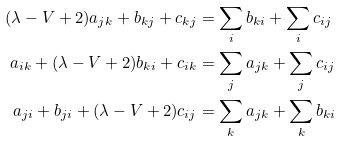<formula> <loc_0><loc_0><loc_500><loc_500>( \lambda - V + 2 ) a _ { j k } + b _ { k j } + c _ { k j } & = \sum _ { i } b _ { k i } + \sum _ { i } c _ { i j } \\ a _ { i k } + ( \lambda - V + 2 ) b _ { k i } + c _ { i k } & = \sum _ { j } a _ { j k } + \sum _ { j } c _ { i j } \\ a _ { j i } + b _ { j i } + ( \lambda - V + 2 ) c _ { i j } & = \sum _ { k } a _ { j k } + \sum _ { k } b _ { k i }</formula> 